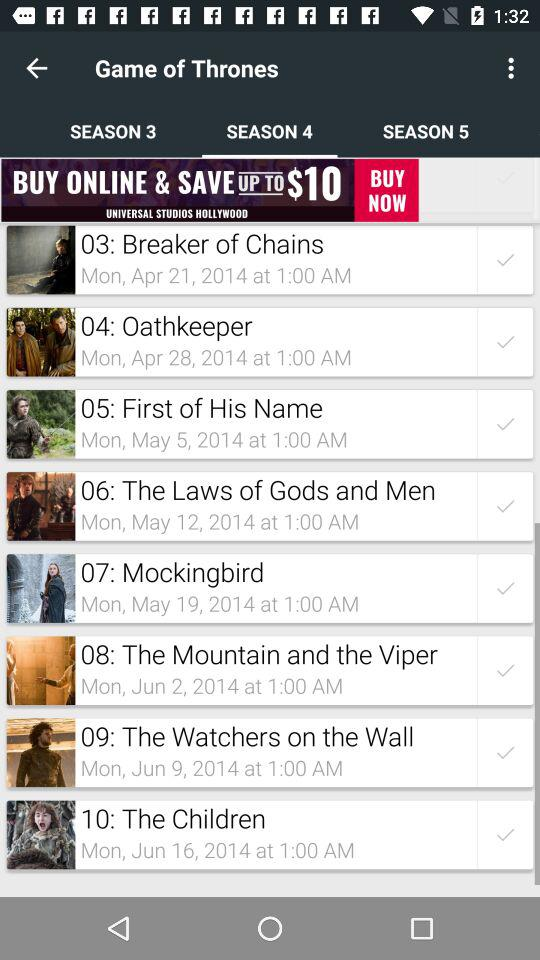Which tab has been selected? The tab "SEASON 4" has been selected. 